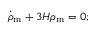<formula> <loc_0><loc_0><loc_500><loc_500>{ \dot { \rho } } _ { m } + 3 H \rho _ { m } = 0 ;</formula> 